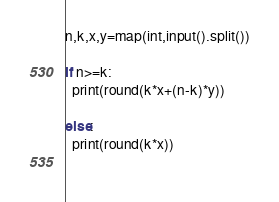Convert code to text. <code><loc_0><loc_0><loc_500><loc_500><_Python_>n,k,x,y=map(int,input().split())

if n>=k:
  print(round(k*x+(n-k)*y))

else:
  print(round(k*x))
      </code> 